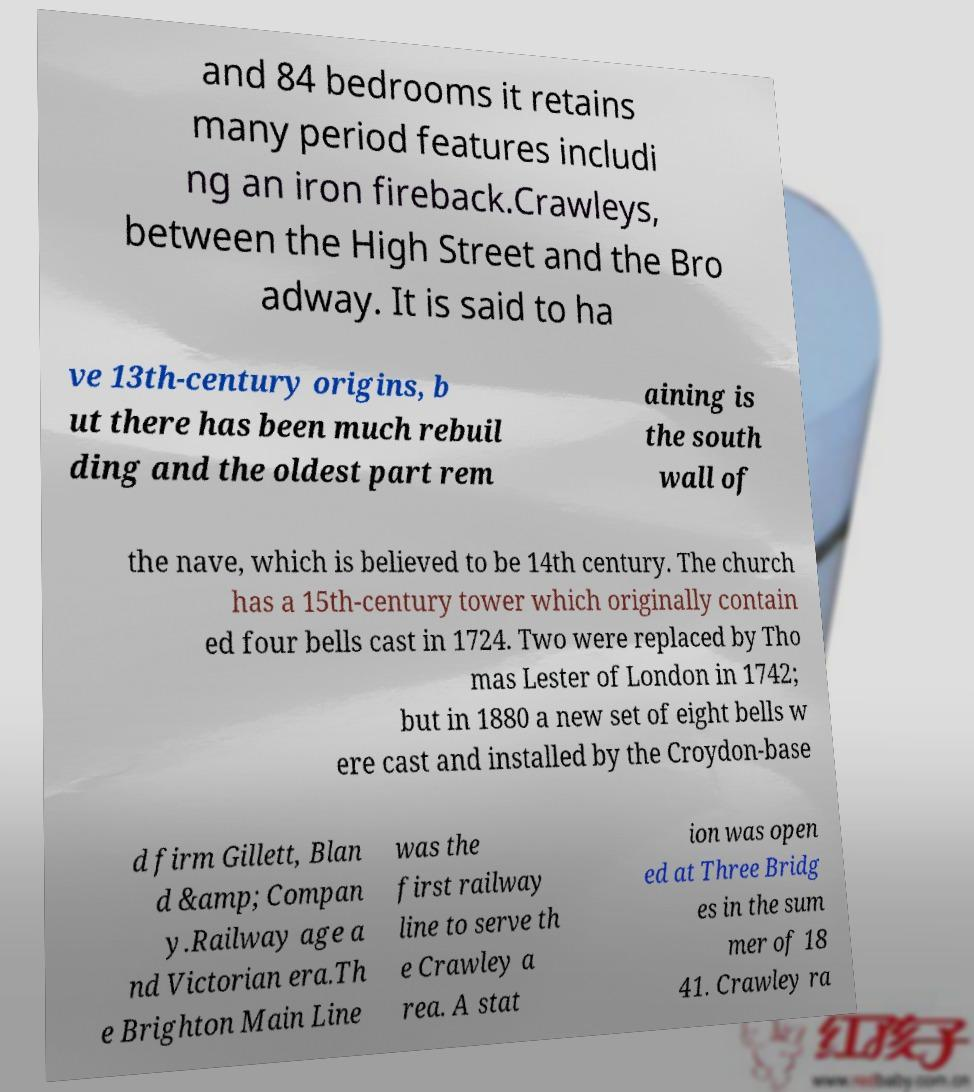I need the written content from this picture converted into text. Can you do that? and 84 bedrooms it retains many period features includi ng an iron fireback.Crawleys, between the High Street and the Bro adway. It is said to ha ve 13th-century origins, b ut there has been much rebuil ding and the oldest part rem aining is the south wall of the nave, which is believed to be 14th century. The church has a 15th-century tower which originally contain ed four bells cast in 1724. Two were replaced by Tho mas Lester of London in 1742; but in 1880 a new set of eight bells w ere cast and installed by the Croydon-base d firm Gillett, Blan d &amp; Compan y.Railway age a nd Victorian era.Th e Brighton Main Line was the first railway line to serve th e Crawley a rea. A stat ion was open ed at Three Bridg es in the sum mer of 18 41. Crawley ra 